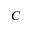Convert formula to latex. <formula><loc_0><loc_0><loc_500><loc_500>C</formula> 